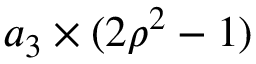Convert formula to latex. <formula><loc_0><loc_0><loc_500><loc_500>a _ { 3 } \times ( 2 \rho ^ { 2 } - 1 )</formula> 